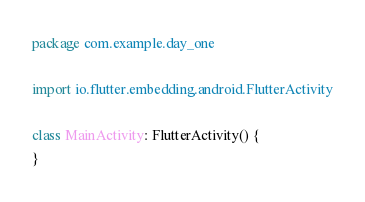Convert code to text. <code><loc_0><loc_0><loc_500><loc_500><_Kotlin_>package com.example.day_one

import io.flutter.embedding.android.FlutterActivity

class MainActivity: FlutterActivity() {
}
</code> 